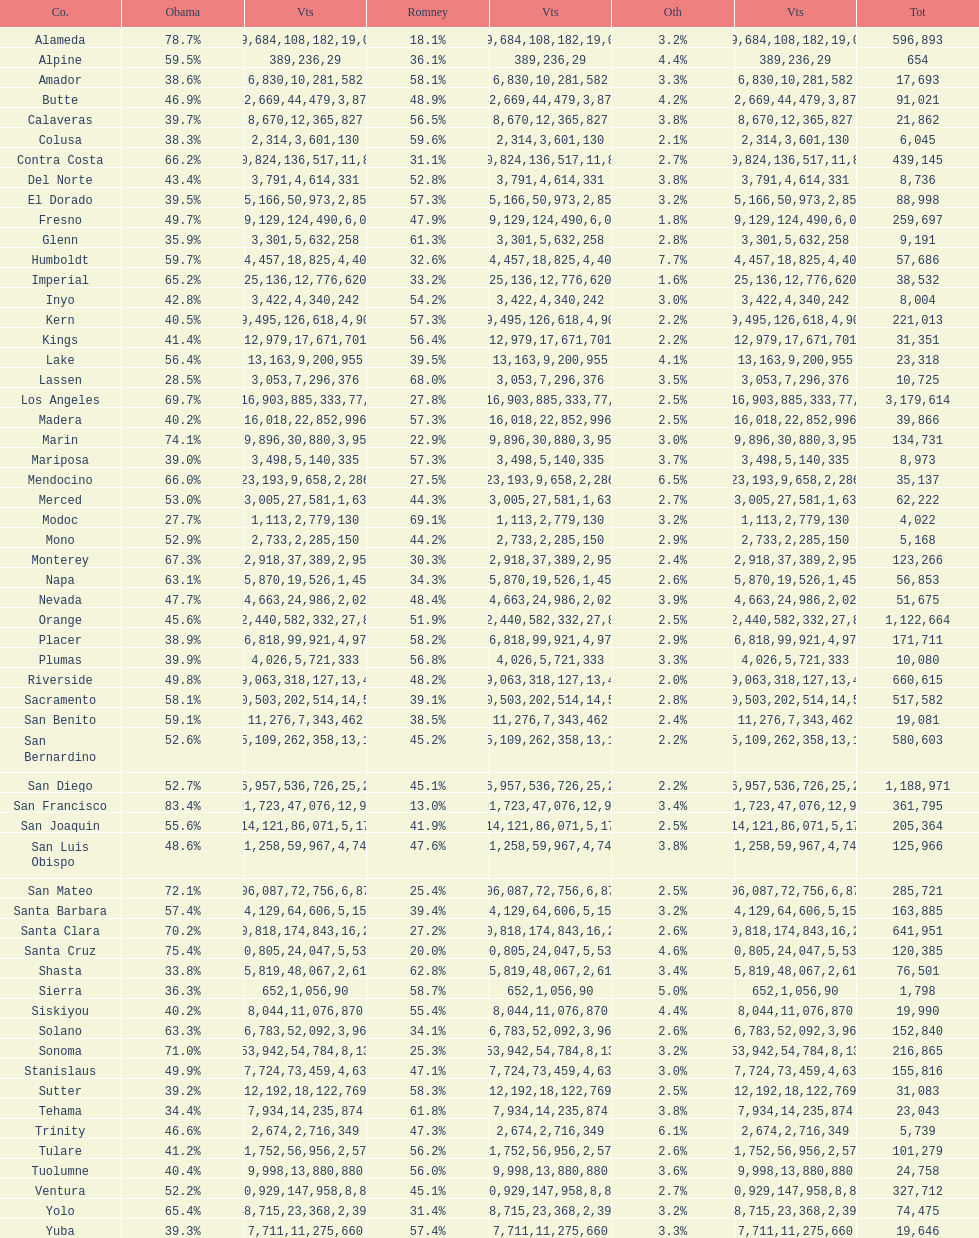Did romney earn more or less votes than obama did in alameda county? Less. 